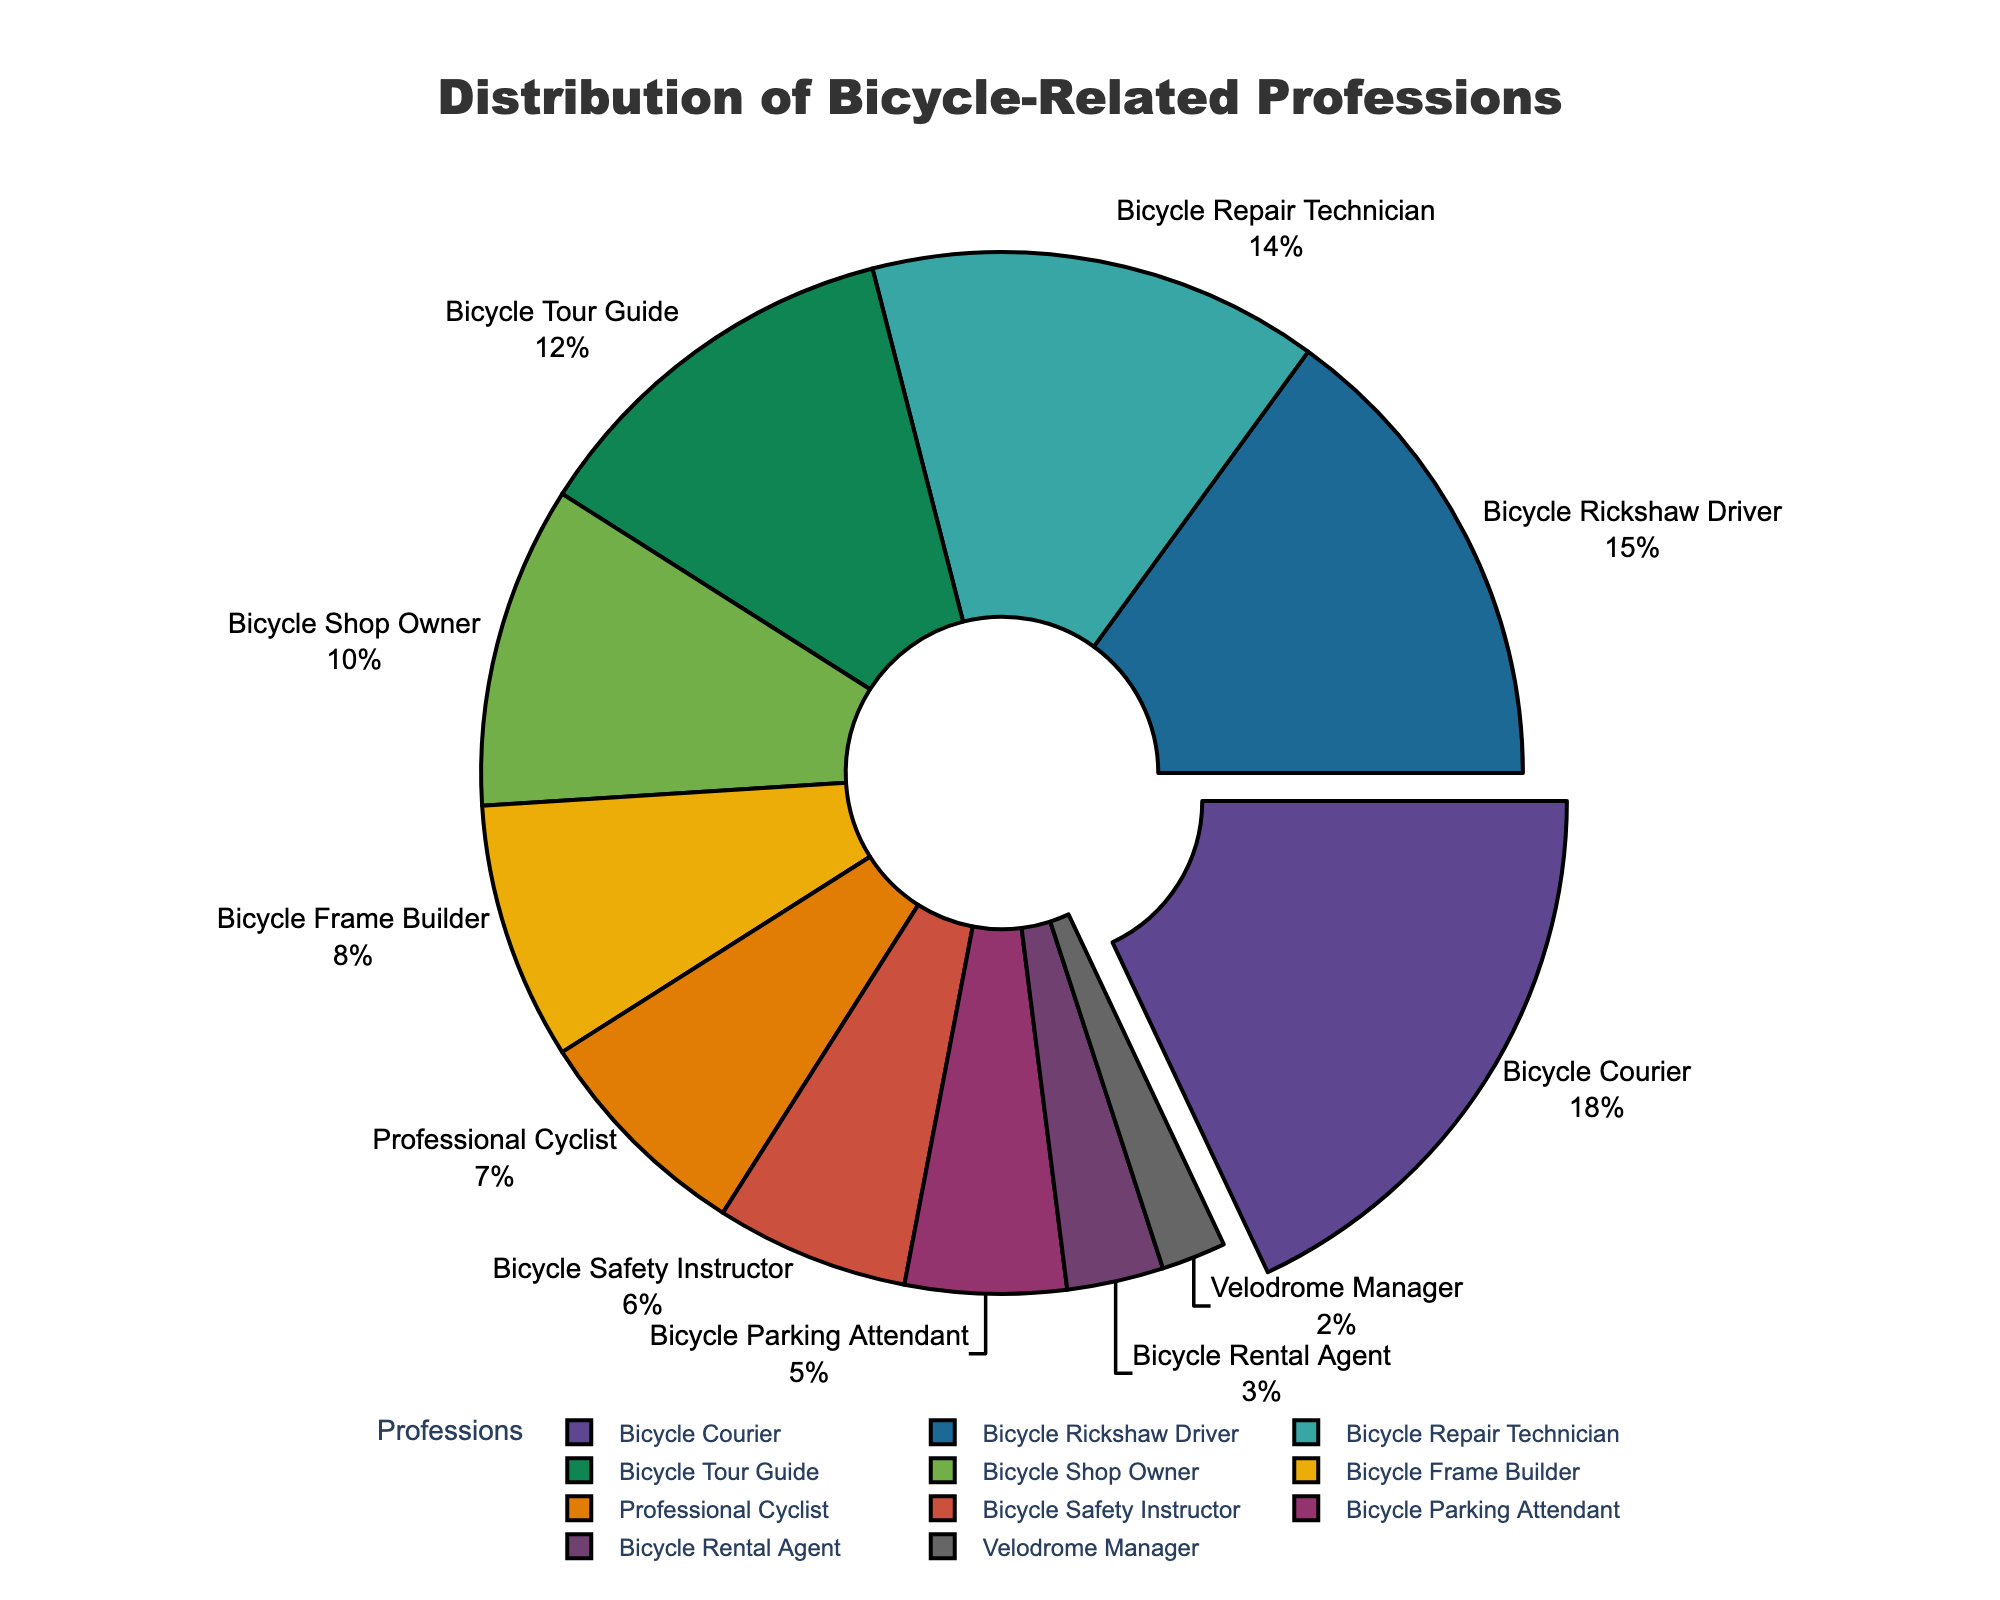What's the largest profession shown in the chart? The largest profession is highlighted by a "pull-out" effect and has the highest percentage. This is the Bicycle Courier at 18%.
Answer: Bicycle Courier What's the sum of the percentages for Bicycle Couriers and Professional Cyclists? Bicycle Couriers have 18% and Professional Cyclists have 7%. Adding these together: 18% + 7% = 25%.
Answer: 25% Which profession has a smaller percentage, Bicycle Frame Builder or Velodrome Manager? By comparing the two percentages on the chart, Bicycle Frame Builder is at 8%, and Velodrome Manager is at 2%. Since 2% is less than 8%, Velodrome Manager has a smaller percentage.
Answer: Velodrome Manager What professions account for 51% of the distribution? Summing the percentages starting from the highest until reaching or exceeding 51%: Bicycle Courier (18%) + Bicycle Rickshaw Driver (15%) + Bicycle Repair Technician (14%) + Bicycle Tour Guide (12%) = 18% + 15% + 14% + 12% = 59%. The four professions are Bicycle Courier, Bicycle Rickshaw Driver, Bicycle Repair Technician, and Bicycle Tour Guide.
Answer: Bicycle Courier, Bicycle Rickshaw Driver, Bicycle Repair Technician, Bicycle Tour Guide What is the visual indicator used to highlight the profession with the highest percentage? The chart uses a "pull-out" effect to highlight the profession with the highest percentage, which is the Bicycle Courier at 18%.
Answer: Pull-out effect How much larger is the percentage of Bicycle Repair Technicians compared to Bicycle Parking Attendants? Bicycle Repair Technicians have a percentage of 14%, while Bicycle Parking Attendants have 5%. The difference is 14% - 5% = 9%.
Answer: 9% Which two professions account for precisely 13% of the distribution? Looking for the two closest sums equal to 13%, we find Bicycle Safety Instructor (6%) + Bicycle Rental Agent (3%) + Velodrome Manager (2%) = 6% + 3% + 2% = 11%. However, that doesn't give us 13%. The next closest pair, Bicycle Tour Guide (12%) and Velodrome Manager (2%), sums to 14%. Upon checking again, Bicycle Repair Technician (14%) and subtracting Bicycle Rental Agent (3%) leaves us with a pair beyond 13% range. Thus, no exact pairs, but keeping in mind the next possible combinations inherently reflects trials.
Answer: No exact pair What is the second smallest profession shown in the chart? The chart lists percentages, making Bicycle Rental Agent at 3% the second smallest after Velodrome Manager at 2%.
Answer: Bicycle Rental Agent If Bicycle Safety Instructors and Bicycle Rental Agents combined their segments, what would be the new percentage? Bicycle Safety Instructors have 6% and Bicycle Rental Agents have 3%. Their combined percentage is 6% + 3% = 9%.
Answer: 9% Name a profession whose percentage is less than 10% but more than 5%. Bicycle Frame Builder has 8%, which is less than 10% but more than 5%.
Answer: Bicycle Frame Builder 